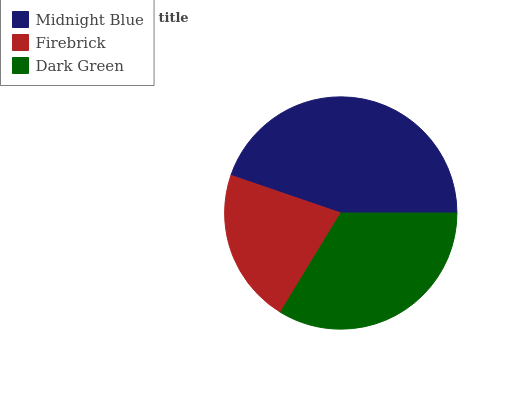Is Firebrick the minimum?
Answer yes or no. Yes. Is Midnight Blue the maximum?
Answer yes or no. Yes. Is Dark Green the minimum?
Answer yes or no. No. Is Dark Green the maximum?
Answer yes or no. No. Is Dark Green greater than Firebrick?
Answer yes or no. Yes. Is Firebrick less than Dark Green?
Answer yes or no. Yes. Is Firebrick greater than Dark Green?
Answer yes or no. No. Is Dark Green less than Firebrick?
Answer yes or no. No. Is Dark Green the high median?
Answer yes or no. Yes. Is Dark Green the low median?
Answer yes or no. Yes. Is Midnight Blue the high median?
Answer yes or no. No. Is Firebrick the low median?
Answer yes or no. No. 